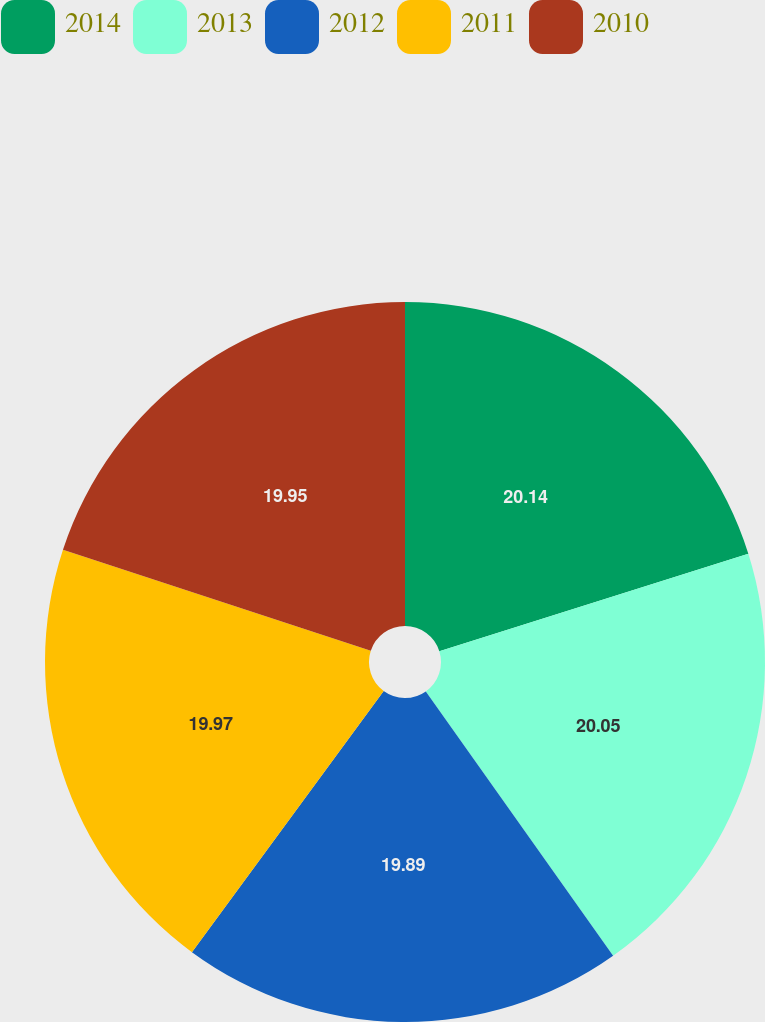Convert chart to OTSL. <chart><loc_0><loc_0><loc_500><loc_500><pie_chart><fcel>2014<fcel>2013<fcel>2012<fcel>2011<fcel>2010<nl><fcel>20.14%<fcel>20.05%<fcel>19.89%<fcel>19.97%<fcel>19.95%<nl></chart> 